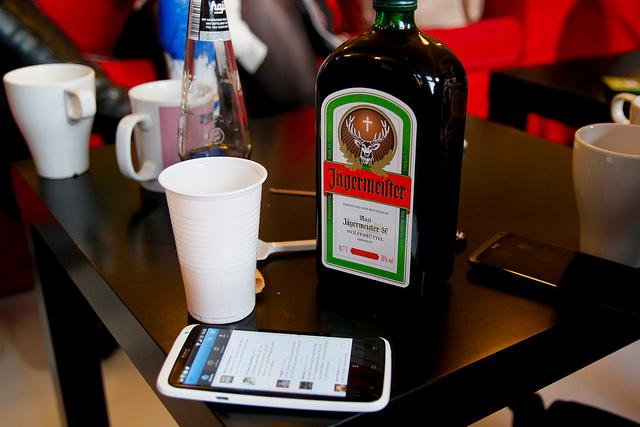What athlete has a last name that is similar to the name on the bottle? jager 